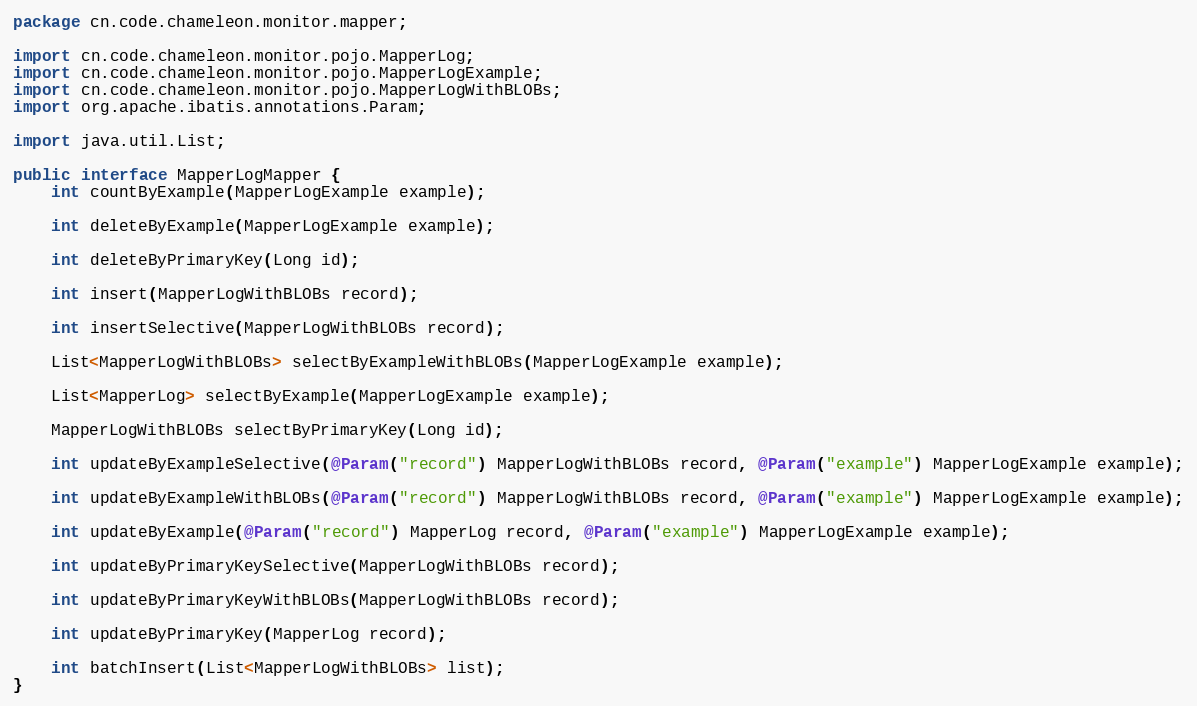Convert code to text. <code><loc_0><loc_0><loc_500><loc_500><_Java_>package cn.code.chameleon.monitor.mapper;

import cn.code.chameleon.monitor.pojo.MapperLog;
import cn.code.chameleon.monitor.pojo.MapperLogExample;
import cn.code.chameleon.monitor.pojo.MapperLogWithBLOBs;
import org.apache.ibatis.annotations.Param;

import java.util.List;

public interface MapperLogMapper {
    int countByExample(MapperLogExample example);

    int deleteByExample(MapperLogExample example);

    int deleteByPrimaryKey(Long id);

    int insert(MapperLogWithBLOBs record);

    int insertSelective(MapperLogWithBLOBs record);

    List<MapperLogWithBLOBs> selectByExampleWithBLOBs(MapperLogExample example);

    List<MapperLog> selectByExample(MapperLogExample example);

    MapperLogWithBLOBs selectByPrimaryKey(Long id);

    int updateByExampleSelective(@Param("record") MapperLogWithBLOBs record, @Param("example") MapperLogExample example);

    int updateByExampleWithBLOBs(@Param("record") MapperLogWithBLOBs record, @Param("example") MapperLogExample example);

    int updateByExample(@Param("record") MapperLog record, @Param("example") MapperLogExample example);

    int updateByPrimaryKeySelective(MapperLogWithBLOBs record);

    int updateByPrimaryKeyWithBLOBs(MapperLogWithBLOBs record);

    int updateByPrimaryKey(MapperLog record);

    int batchInsert(List<MapperLogWithBLOBs> list);
}</code> 